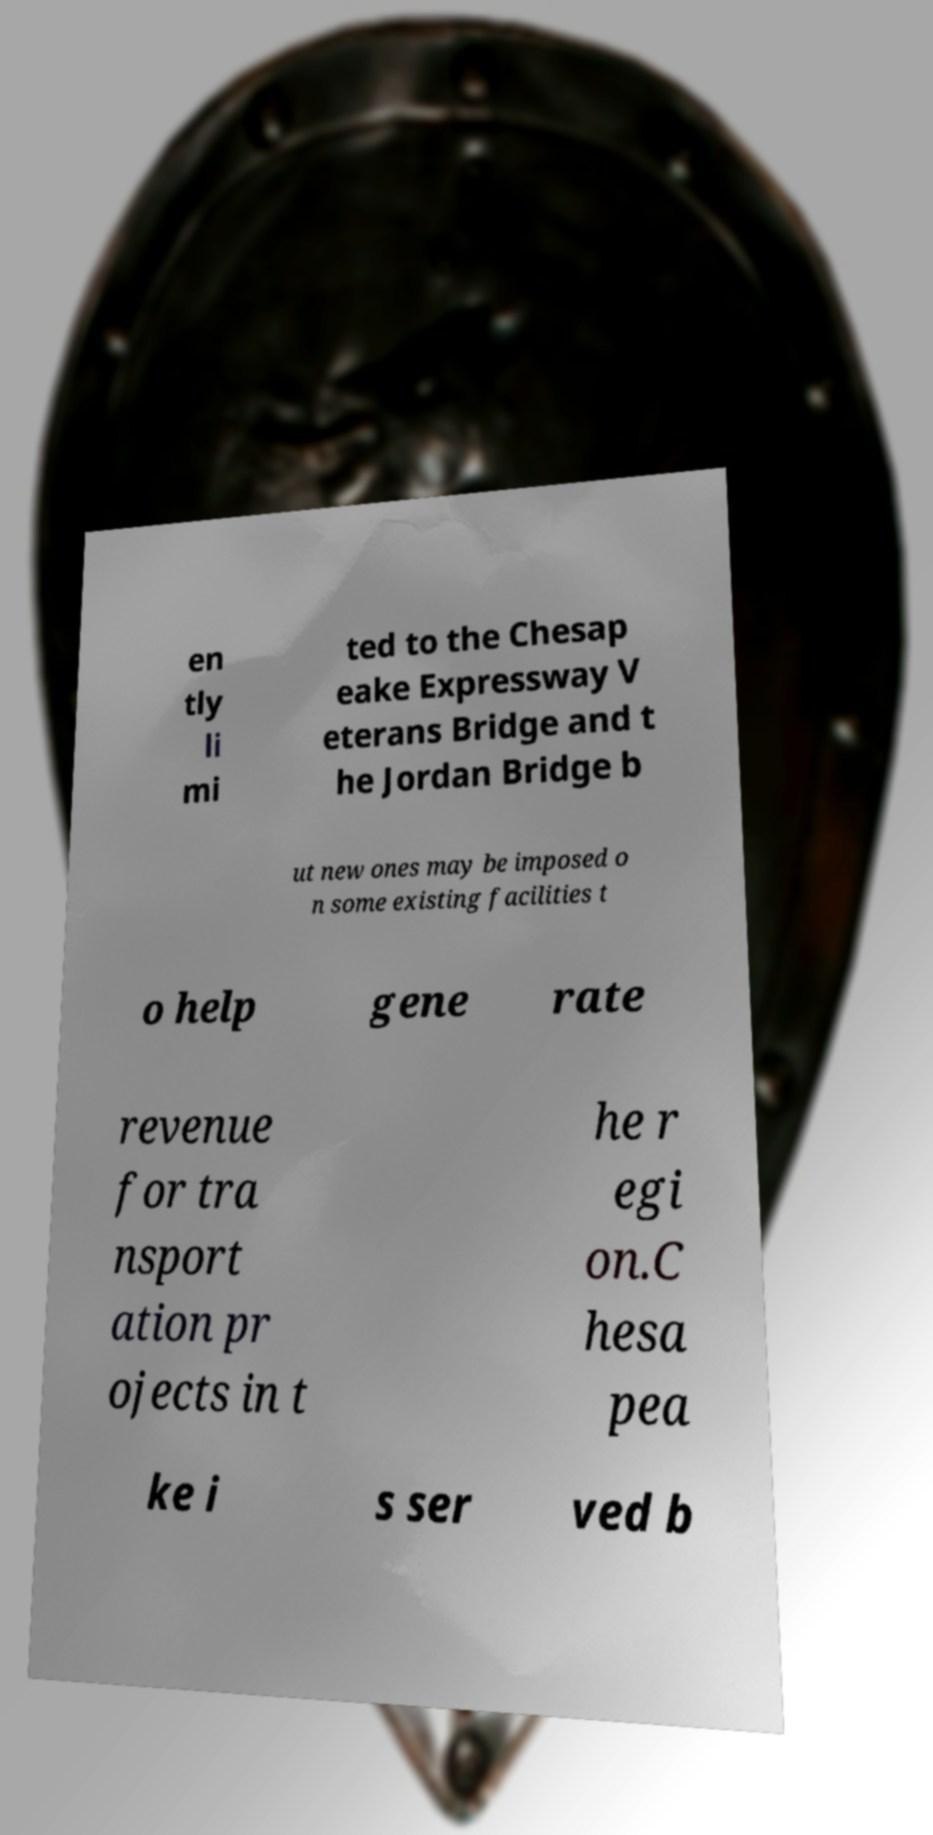I need the written content from this picture converted into text. Can you do that? en tly li mi ted to the Chesap eake Expressway V eterans Bridge and t he Jordan Bridge b ut new ones may be imposed o n some existing facilities t o help gene rate revenue for tra nsport ation pr ojects in t he r egi on.C hesa pea ke i s ser ved b 